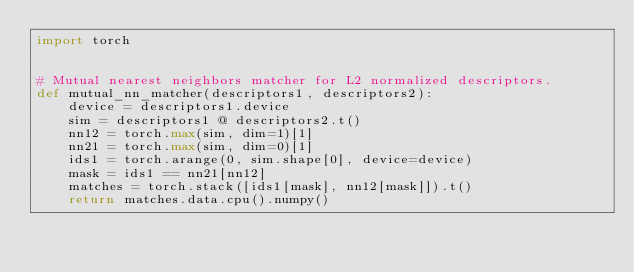<code> <loc_0><loc_0><loc_500><loc_500><_Python_>import torch


# Mutual nearest neighbors matcher for L2 normalized descriptors.
def mutual_nn_matcher(descriptors1, descriptors2):
    device = descriptors1.device
    sim = descriptors1 @ descriptors2.t()
    nn12 = torch.max(sim, dim=1)[1]
    nn21 = torch.max(sim, dim=0)[1]
    ids1 = torch.arange(0, sim.shape[0], device=device)
    mask = ids1 == nn21[nn12]
    matches = torch.stack([ids1[mask], nn12[mask]]).t()
    return matches.data.cpu().numpy()
</code> 